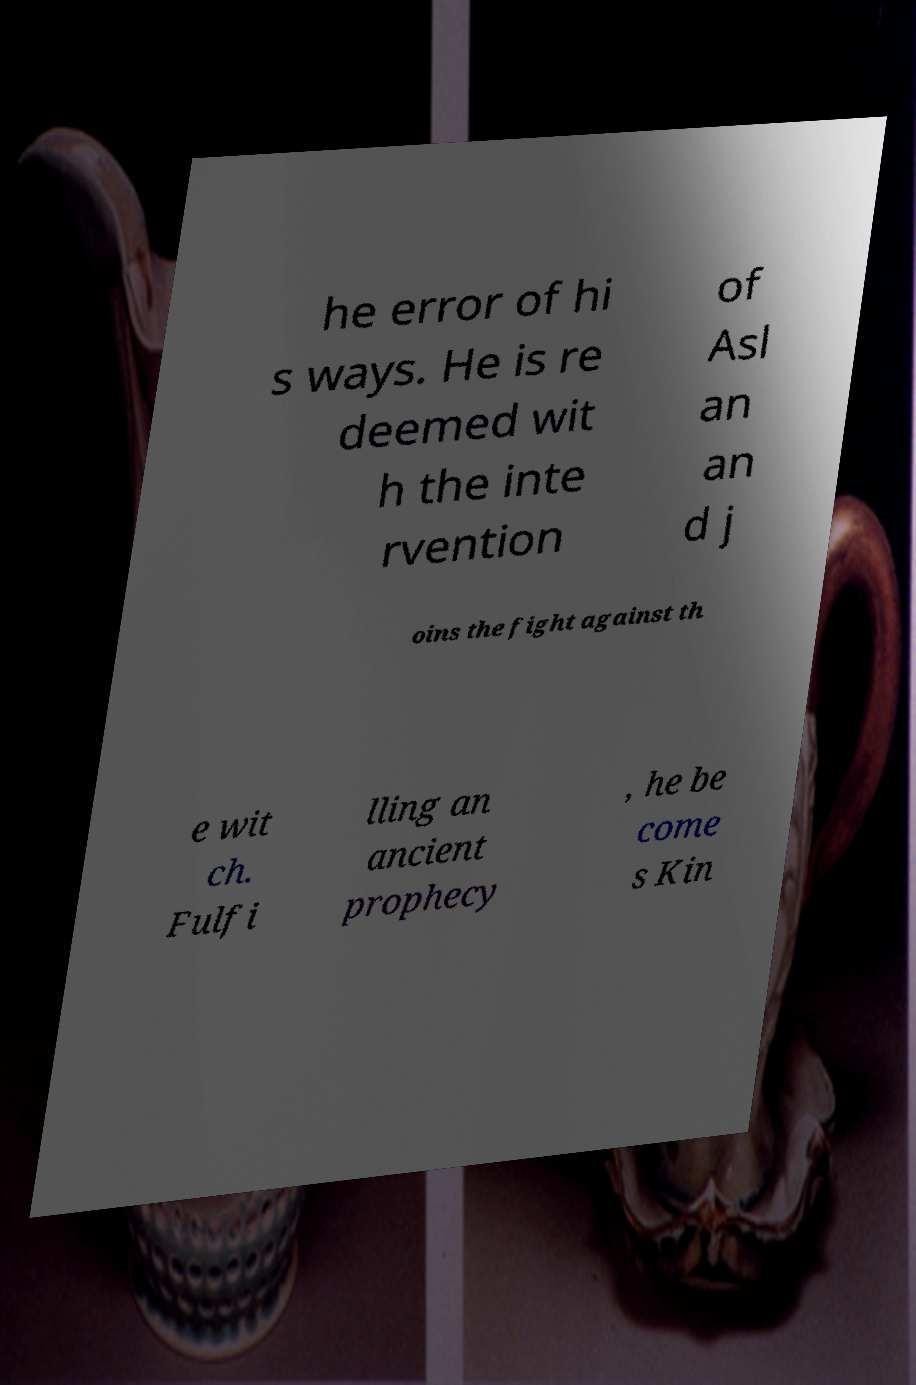I need the written content from this picture converted into text. Can you do that? he error of hi s ways. He is re deemed wit h the inte rvention of Asl an an d j oins the fight against th e wit ch. Fulfi lling an ancient prophecy , he be come s Kin 